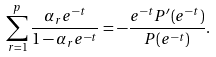Convert formula to latex. <formula><loc_0><loc_0><loc_500><loc_500>\sum _ { r = 1 } ^ { p } \frac { \alpha _ { r } e ^ { - t } } { 1 - \alpha _ { r } e ^ { - t } } = - \frac { e ^ { - t } P ^ { \prime } ( e ^ { - t } ) } { P ( e ^ { - t } ) } .</formula> 